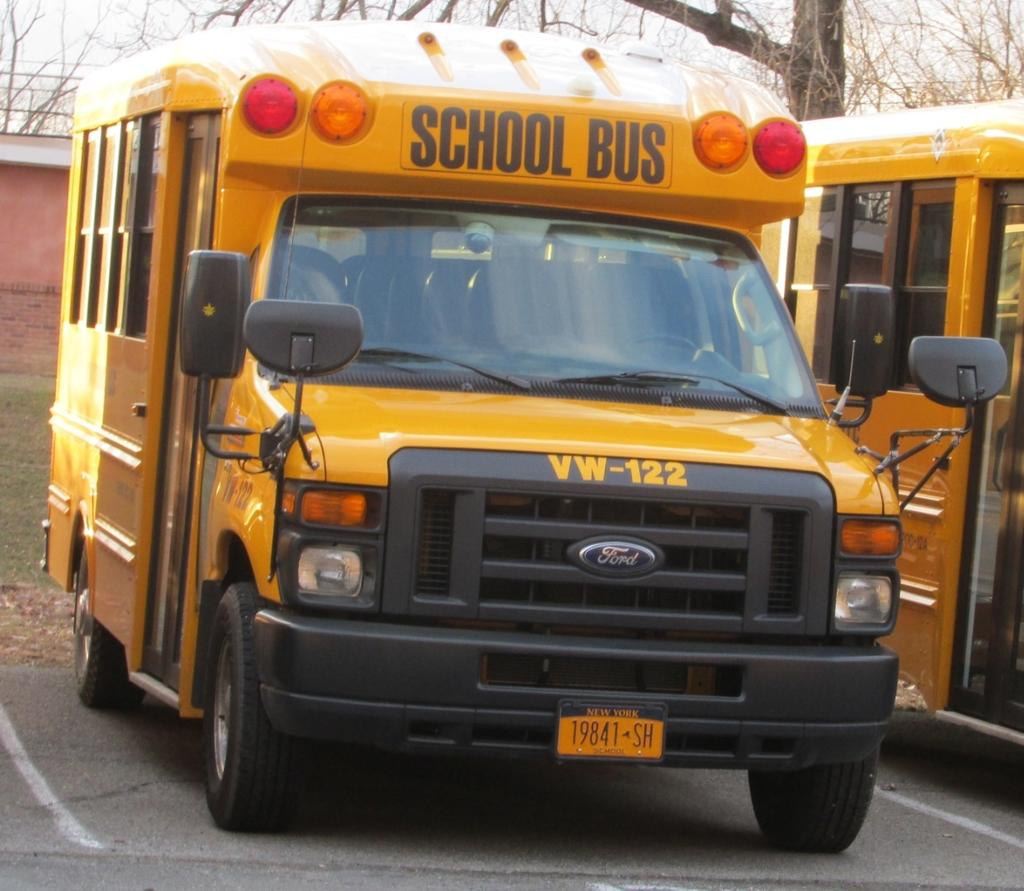<image>
Write a terse but informative summary of the picture. The yellow New York school bus is numbered VW-122. 